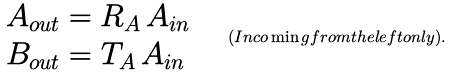Convert formula to latex. <formula><loc_0><loc_0><loc_500><loc_500>\begin{array} { l } A _ { o u t } = R _ { A } \, A _ { i n } \\ B _ { o u t } = T _ { A } \, A _ { i n } \end{array} \quad ( I n c o \min g f r o m t h e l e f t o n l y ) .</formula> 